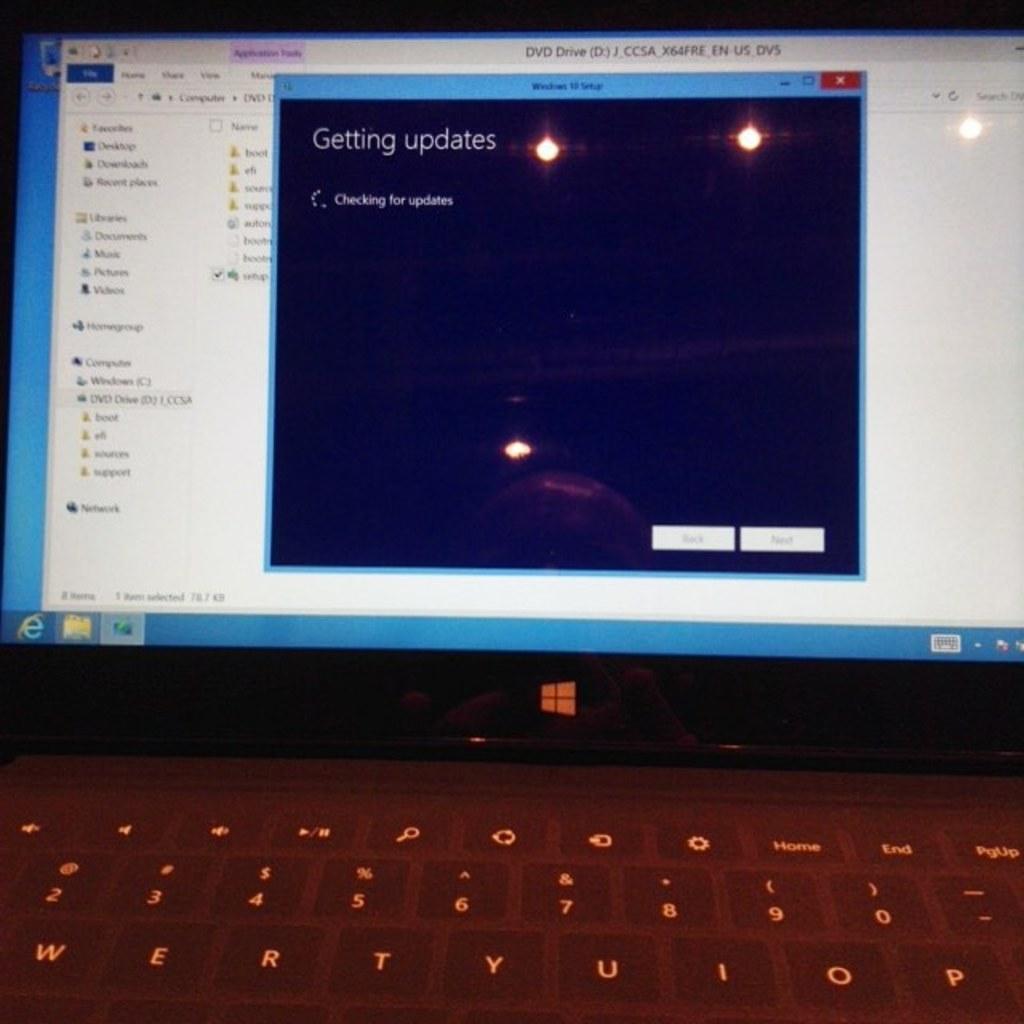What is the computer getting?
Keep it short and to the point. Updates. What is the computer checking for?
Your answer should be compact. Updates. 